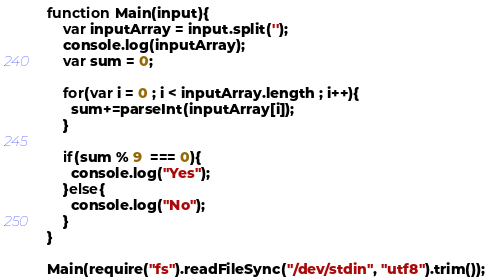<code> <loc_0><loc_0><loc_500><loc_500><_JavaScript_>function Main(input){
    var inputArray = input.split('');
    console.log(inputArray);
    var sum = 0;

    for(var i = 0 ; i < inputArray.length ; i++){
      sum+=parseInt(inputArray[i]);
    }

    if(sum % 9  === 0){
      console.log("Yes");
    }else{
      console.log("No");
    }
}

Main(require("fs").readFileSync("/dev/stdin", "utf8").trim());</code> 